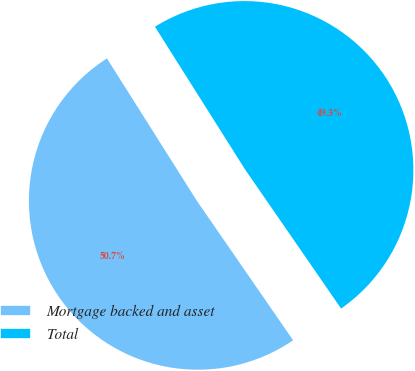Convert chart. <chart><loc_0><loc_0><loc_500><loc_500><pie_chart><fcel>Mortgage backed and asset<fcel>Total<nl><fcel>50.65%<fcel>49.35%<nl></chart> 